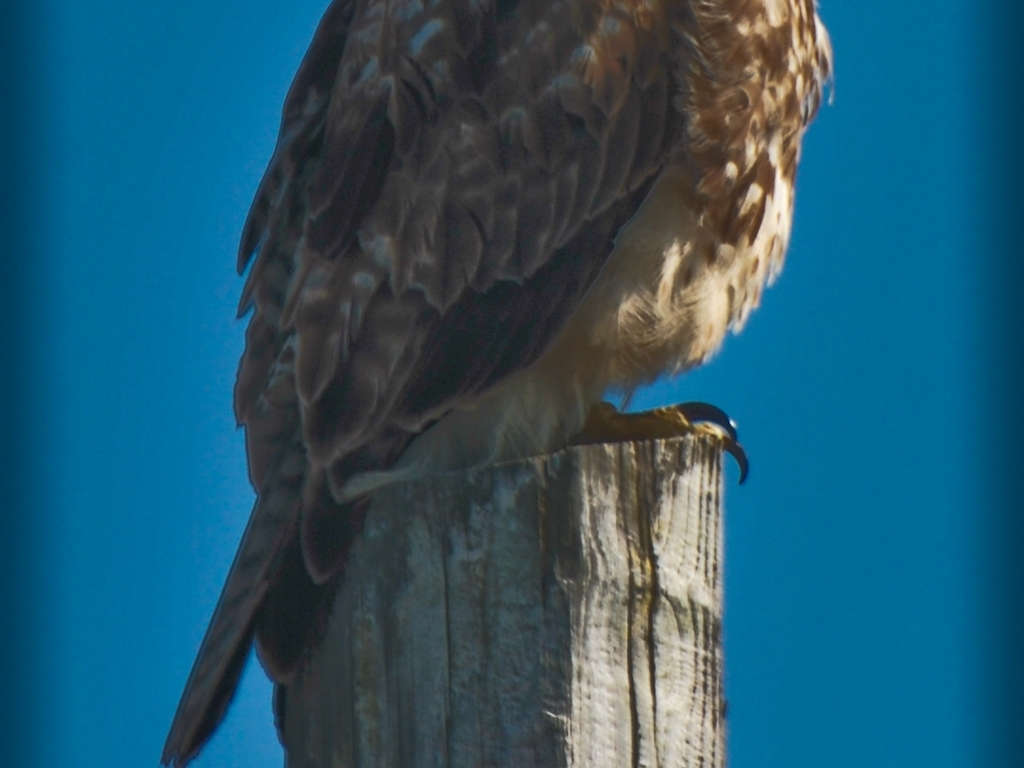Is the subject of the shot placed off-center? The subject, which appears to be a bird perched on top of a post, is actually placed slightly off-center in the frame, leaning towards the right-hand side. This composition may add a dynamic quality to the image, guiding the viewer's eye through the scene and suggesting motion or anticipation. 